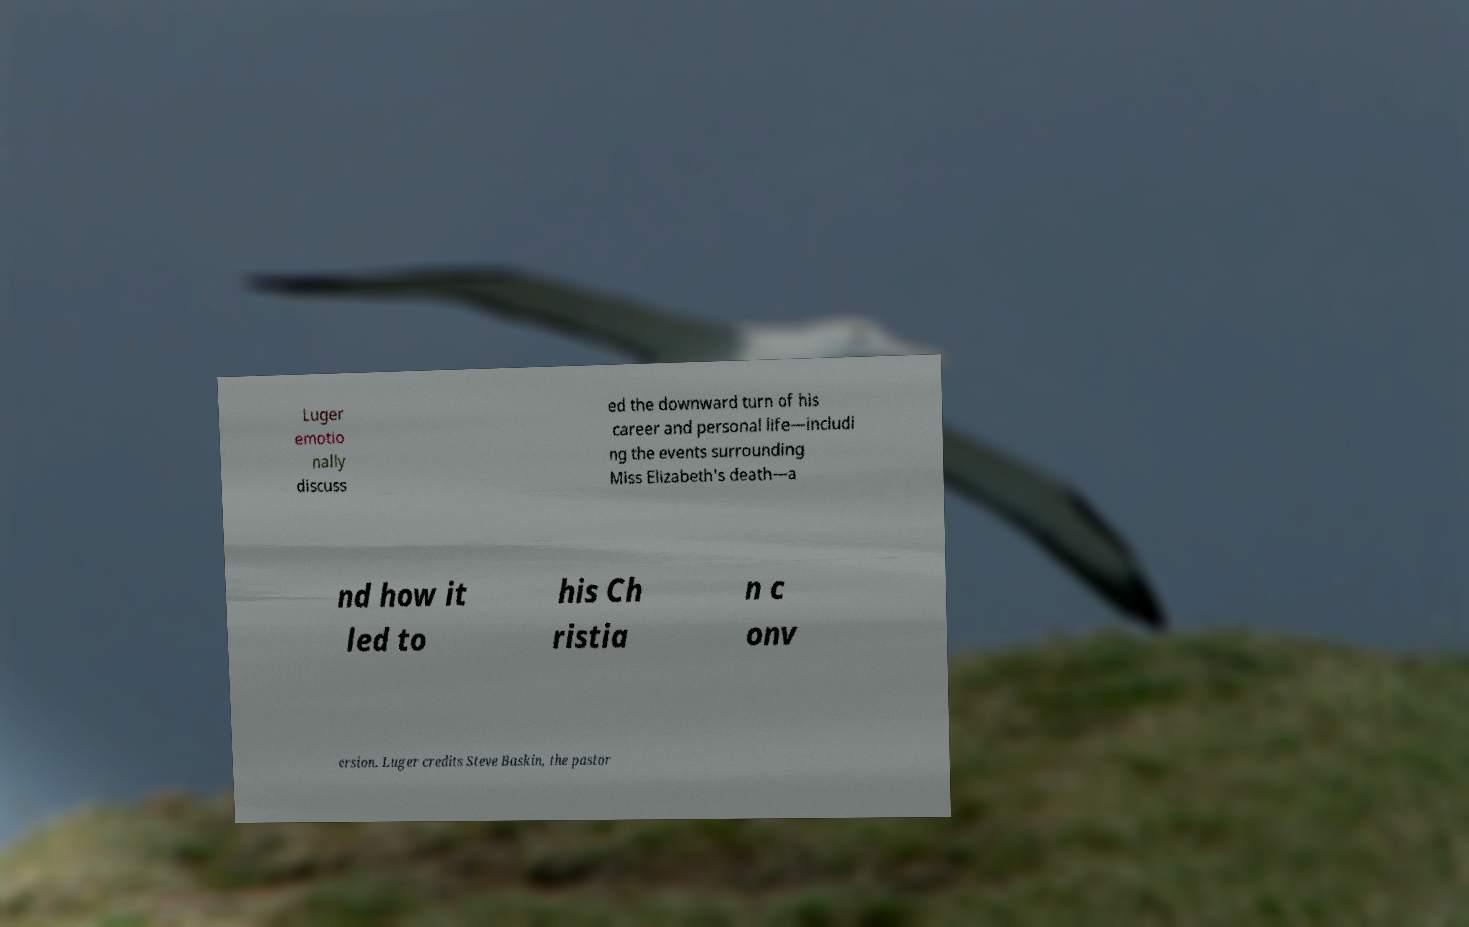Can you read and provide the text displayed in the image?This photo seems to have some interesting text. Can you extract and type it out for me? Luger emotio nally discuss ed the downward turn of his career and personal life—includi ng the events surrounding Miss Elizabeth's death—a nd how it led to his Ch ristia n c onv ersion. Luger credits Steve Baskin, the pastor 